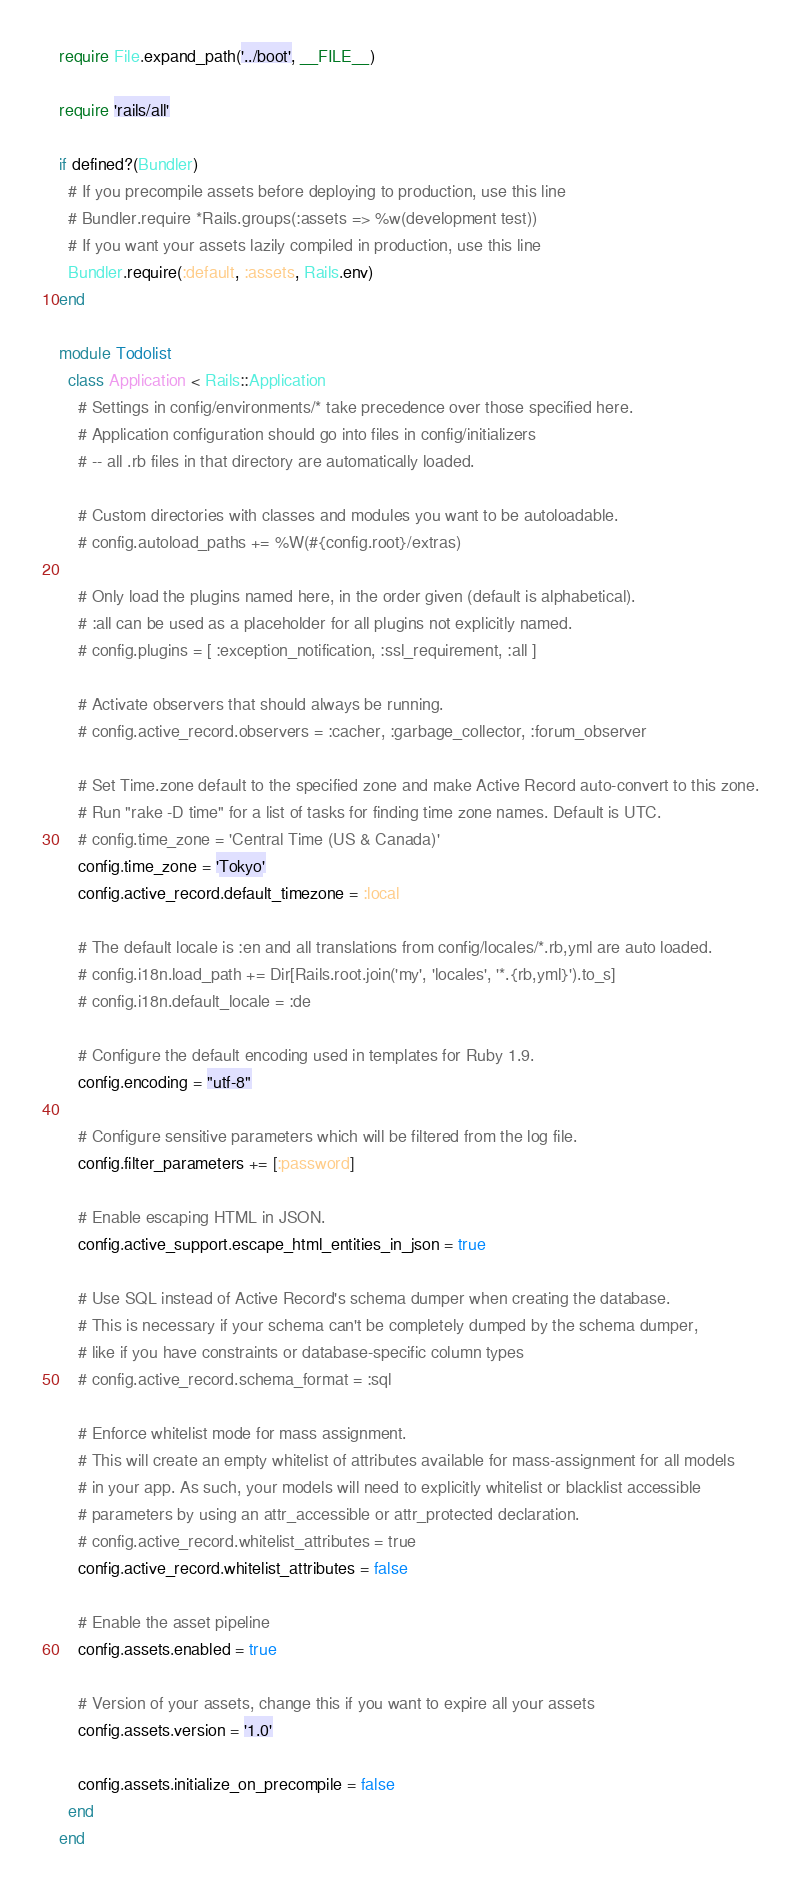<code> <loc_0><loc_0><loc_500><loc_500><_Ruby_>require File.expand_path('../boot', __FILE__)

require 'rails/all'

if defined?(Bundler)
  # If you precompile assets before deploying to production, use this line
  # Bundler.require *Rails.groups(:assets => %w(development test))
  # If you want your assets lazily compiled in production, use this line
  Bundler.require(:default, :assets, Rails.env)
end

module Todolist
  class Application < Rails::Application
    # Settings in config/environments/* take precedence over those specified here.
    # Application configuration should go into files in config/initializers
    # -- all .rb files in that directory are automatically loaded.

    # Custom directories with classes and modules you want to be autoloadable.
    # config.autoload_paths += %W(#{config.root}/extras)

    # Only load the plugins named here, in the order given (default is alphabetical).
    # :all can be used as a placeholder for all plugins not explicitly named.
    # config.plugins = [ :exception_notification, :ssl_requirement, :all ]

    # Activate observers that should always be running.
    # config.active_record.observers = :cacher, :garbage_collector, :forum_observer

    # Set Time.zone default to the specified zone and make Active Record auto-convert to this zone.
    # Run "rake -D time" for a list of tasks for finding time zone names. Default is UTC.
    # config.time_zone = 'Central Time (US & Canada)'
    config.time_zone = 'Tokyo'
    config.active_record.default_timezone = :local

    # The default locale is :en and all translations from config/locales/*.rb,yml are auto loaded.
    # config.i18n.load_path += Dir[Rails.root.join('my', 'locales', '*.{rb,yml}').to_s]
    # config.i18n.default_locale = :de

    # Configure the default encoding used in templates for Ruby 1.9.
    config.encoding = "utf-8"

    # Configure sensitive parameters which will be filtered from the log file.
    config.filter_parameters += [:password]

    # Enable escaping HTML in JSON.
    config.active_support.escape_html_entities_in_json = true

    # Use SQL instead of Active Record's schema dumper when creating the database.
    # This is necessary if your schema can't be completely dumped by the schema dumper,
    # like if you have constraints or database-specific column types
    # config.active_record.schema_format = :sql

    # Enforce whitelist mode for mass assignment.
    # This will create an empty whitelist of attributes available for mass-assignment for all models
    # in your app. As such, your models will need to explicitly whitelist or blacklist accessible
    # parameters by using an attr_accessible or attr_protected declaration.
    # config.active_record.whitelist_attributes = true
    config.active_record.whitelist_attributes = false

    # Enable the asset pipeline
    config.assets.enabled = true

    # Version of your assets, change this if you want to expire all your assets
    config.assets.version = '1.0'

    config.assets.initialize_on_precompile = false
  end
end
</code> 